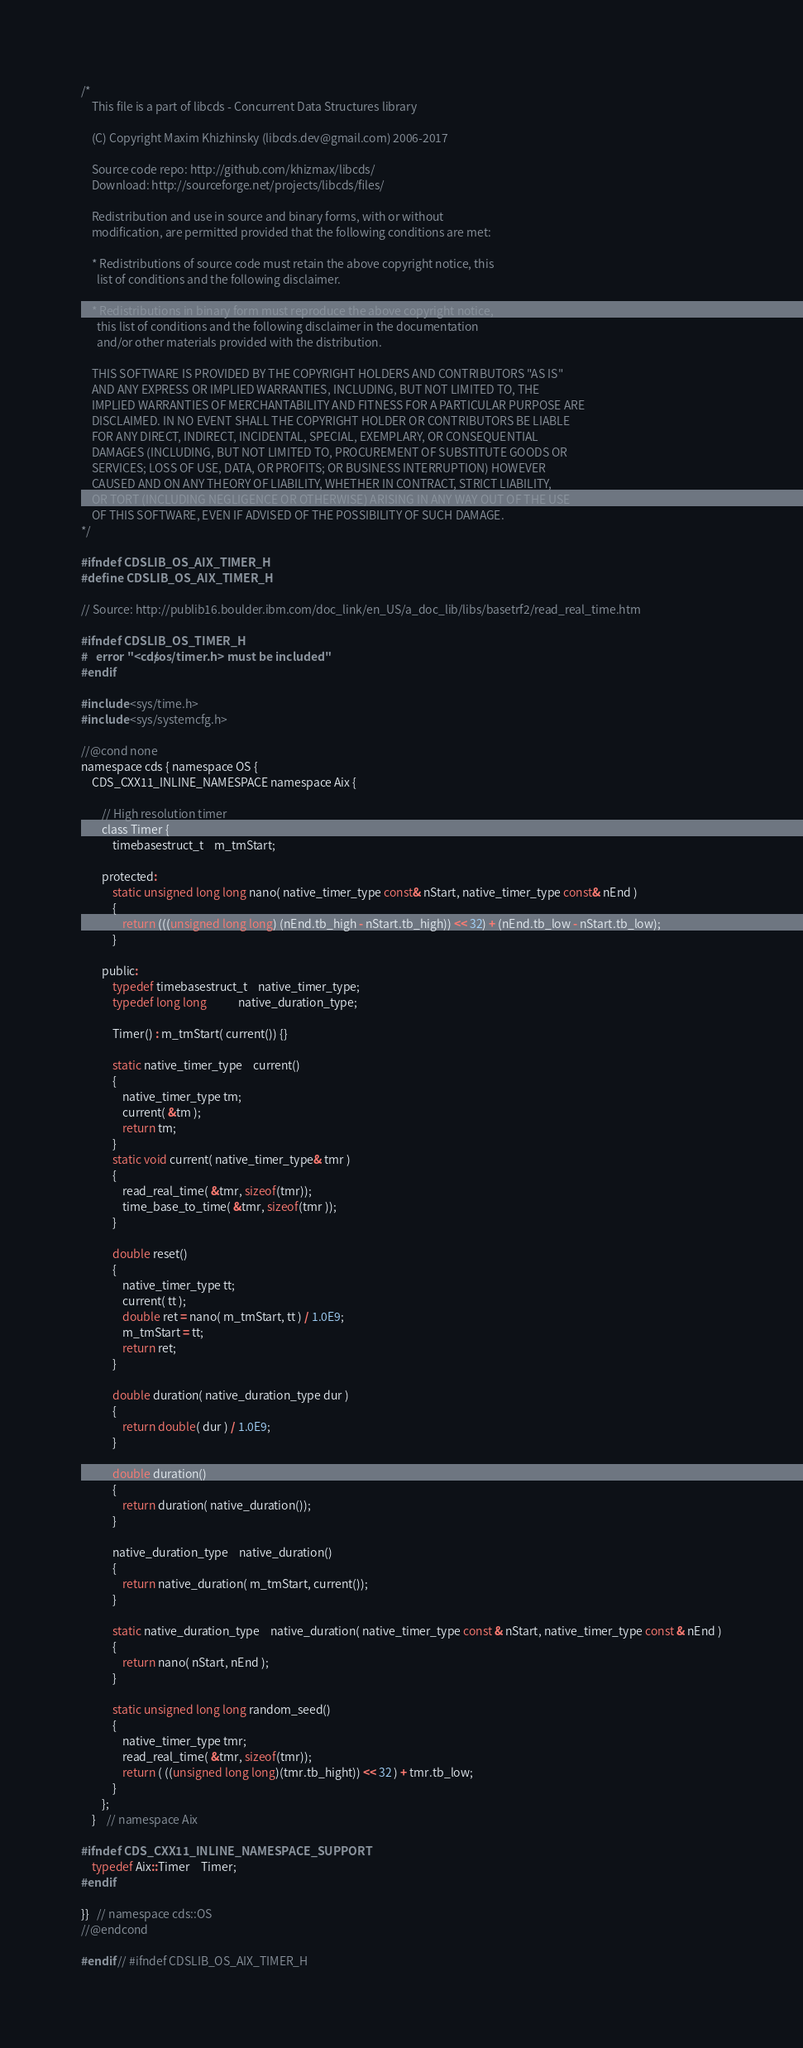Convert code to text. <code><loc_0><loc_0><loc_500><loc_500><_C_>/*
    This file is a part of libcds - Concurrent Data Structures library

    (C) Copyright Maxim Khizhinsky (libcds.dev@gmail.com) 2006-2017

    Source code repo: http://github.com/khizmax/libcds/
    Download: http://sourceforge.net/projects/libcds/files/

    Redistribution and use in source and binary forms, with or without
    modification, are permitted provided that the following conditions are met:

    * Redistributions of source code must retain the above copyright notice, this
      list of conditions and the following disclaimer.

    * Redistributions in binary form must reproduce the above copyright notice,
      this list of conditions and the following disclaimer in the documentation
      and/or other materials provided with the distribution.

    THIS SOFTWARE IS PROVIDED BY THE COPYRIGHT HOLDERS AND CONTRIBUTORS "AS IS"
    AND ANY EXPRESS OR IMPLIED WARRANTIES, INCLUDING, BUT NOT LIMITED TO, THE
    IMPLIED WARRANTIES OF MERCHANTABILITY AND FITNESS FOR A PARTICULAR PURPOSE ARE
    DISCLAIMED. IN NO EVENT SHALL THE COPYRIGHT HOLDER OR CONTRIBUTORS BE LIABLE
    FOR ANY DIRECT, INDIRECT, INCIDENTAL, SPECIAL, EXEMPLARY, OR CONSEQUENTIAL
    DAMAGES (INCLUDING, BUT NOT LIMITED TO, PROCUREMENT OF SUBSTITUTE GOODS OR
    SERVICES; LOSS OF USE, DATA, OR PROFITS; OR BUSINESS INTERRUPTION) HOWEVER
    CAUSED AND ON ANY THEORY OF LIABILITY, WHETHER IN CONTRACT, STRICT LIABILITY,
    OR TORT (INCLUDING NEGLIGENCE OR OTHERWISE) ARISING IN ANY WAY OUT OF THE USE
    OF THIS SOFTWARE, EVEN IF ADVISED OF THE POSSIBILITY OF SUCH DAMAGE.
*/

#ifndef CDSLIB_OS_AIX_TIMER_H
#define CDSLIB_OS_AIX_TIMER_H

// Source: http://publib16.boulder.ibm.com/doc_link/en_US/a_doc_lib/libs/basetrf2/read_real_time.htm

#ifndef CDSLIB_OS_TIMER_H
#   error "<cds/os/timer.h> must be included"
#endif

#include <sys/time.h>
#include <sys/systemcfg.h>

//@cond none
namespace cds { namespace OS {
    CDS_CXX11_INLINE_NAMESPACE namespace Aix {

        // High resolution timer
        class Timer {
            timebasestruct_t    m_tmStart;

        protected:
            static unsigned long long nano( native_timer_type const& nStart, native_timer_type const& nEnd )
            {
                return (((unsigned long long) (nEnd.tb_high - nStart.tb_high)) << 32) + (nEnd.tb_low - nStart.tb_low);
            }

        public:
            typedef timebasestruct_t    native_timer_type;
            typedef long long            native_duration_type;

            Timer() : m_tmStart( current()) {}

            static native_timer_type    current()
            {
                native_timer_type tm;
                current( &tm );
                return tm;
            }
            static void current( native_timer_type& tmr )
            {
                read_real_time( &tmr, sizeof(tmr));
                time_base_to_time( &tmr, sizeof(tmr ));
            }

            double reset()
            {
                native_timer_type tt;
                current( tt );
                double ret = nano( m_tmStart, tt ) / 1.0E9;
                m_tmStart = tt;
                return ret;
            }

            double duration( native_duration_type dur )
            {
                return double( dur ) / 1.0E9;
            }

            double duration()
            {
                return duration( native_duration());
            }

            native_duration_type    native_duration()
            {
                return native_duration( m_tmStart, current());
            }

            static native_duration_type    native_duration( native_timer_type const & nStart, native_timer_type const & nEnd )
            {
                return nano( nStart, nEnd );
            }

            static unsigned long long random_seed()
            {
                native_timer_type tmr;
                read_real_time( &tmr, sizeof(tmr));
                return ( ((unsigned long long)(tmr.tb_hight)) << 32 ) + tmr.tb_low;
            }
        };
    }    // namespace Aix

#ifndef CDS_CXX11_INLINE_NAMESPACE_SUPPORT
    typedef Aix::Timer    Timer;
#endif

}}   // namespace cds::OS
//@endcond

#endif // #ifndef CDSLIB_OS_AIX_TIMER_H
</code> 